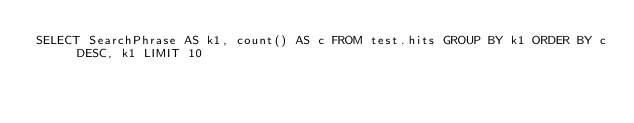Convert code to text. <code><loc_0><loc_0><loc_500><loc_500><_SQL_>SELECT SearchPhrase AS k1, count() AS c FROM test.hits GROUP BY k1 ORDER BY c DESC, k1 LIMIT 10
</code> 